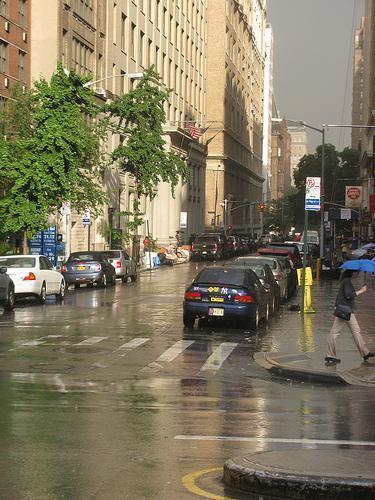How many crosswalks are visible?
Give a very brief answer. 1. 